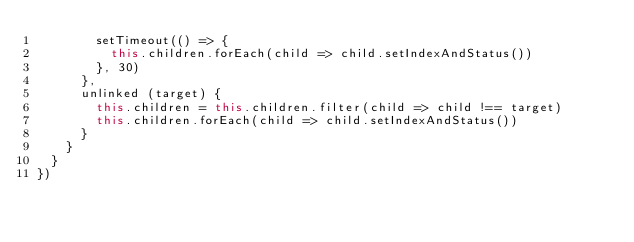<code> <loc_0><loc_0><loc_500><loc_500><_JavaScript_>        setTimeout(() => {
          this.children.forEach(child => child.setIndexAndStatus())
        }, 30)
      },
      unlinked (target) {
        this.children = this.children.filter(child => child !== target)
        this.children.forEach(child => child.setIndexAndStatus())
      }
    }
  }
})</code> 